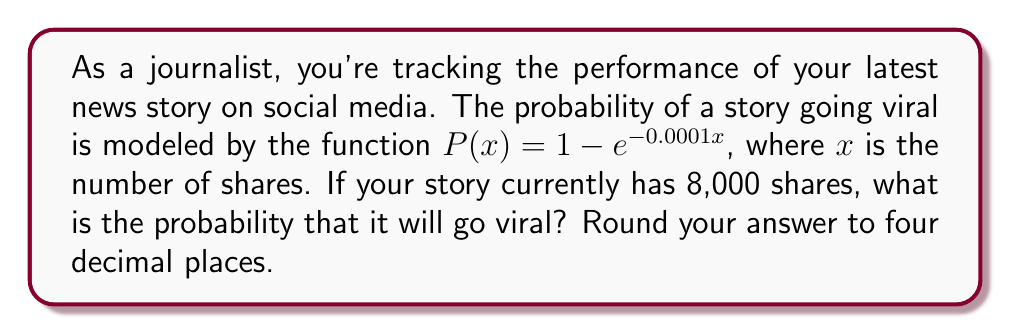Show me your answer to this math problem. To solve this problem, we need to follow these steps:

1. Understand the given function:
   The probability of a story going viral is given by the function:
   $P(x) = 1 - e^{-0.0001x}$
   where $x$ is the number of shares.

2. Insert the given number of shares:
   We know that the story has 8,000 shares, so we substitute $x = 8000$ into the function.

3. Calculate the probability:
   $P(8000) = 1 - e^{-0.0001(8000)}$
   $= 1 - e^{-0.8}$

4. Evaluate the exponential function:
   $e^{-0.8} \approx 0.4493289641$

5. Subtract from 1:
   $1 - 0.4493289641 \approx 0.5506710359$

6. Round to four decimal places:
   0.5507

Therefore, the probability of the story going viral with 8,000 shares is approximately 0.5507 or 55.07%.
Answer: 0.5507 